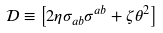<formula> <loc_0><loc_0><loc_500><loc_500>\mathcal { D } \equiv \left [ 2 \eta \sigma _ { a b } \sigma ^ { a b } + \zeta \theta ^ { 2 } \right ]</formula> 